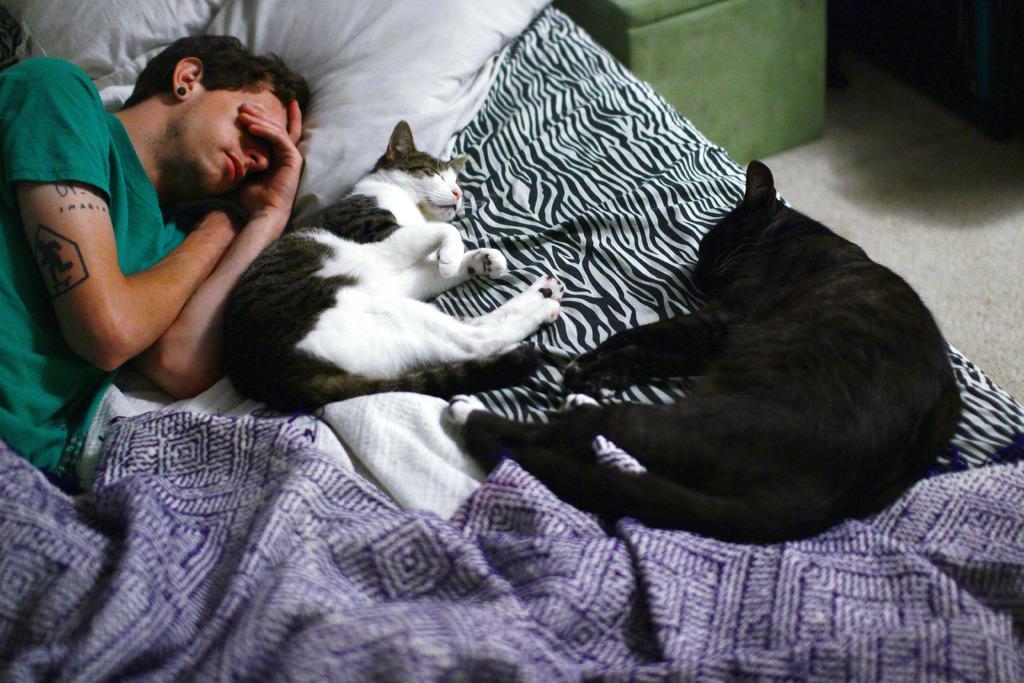Could you give a brief overview of what you see in this image? There is a man laying on the bed. This is blanket and there are cats. And this is pillow. This is floor 